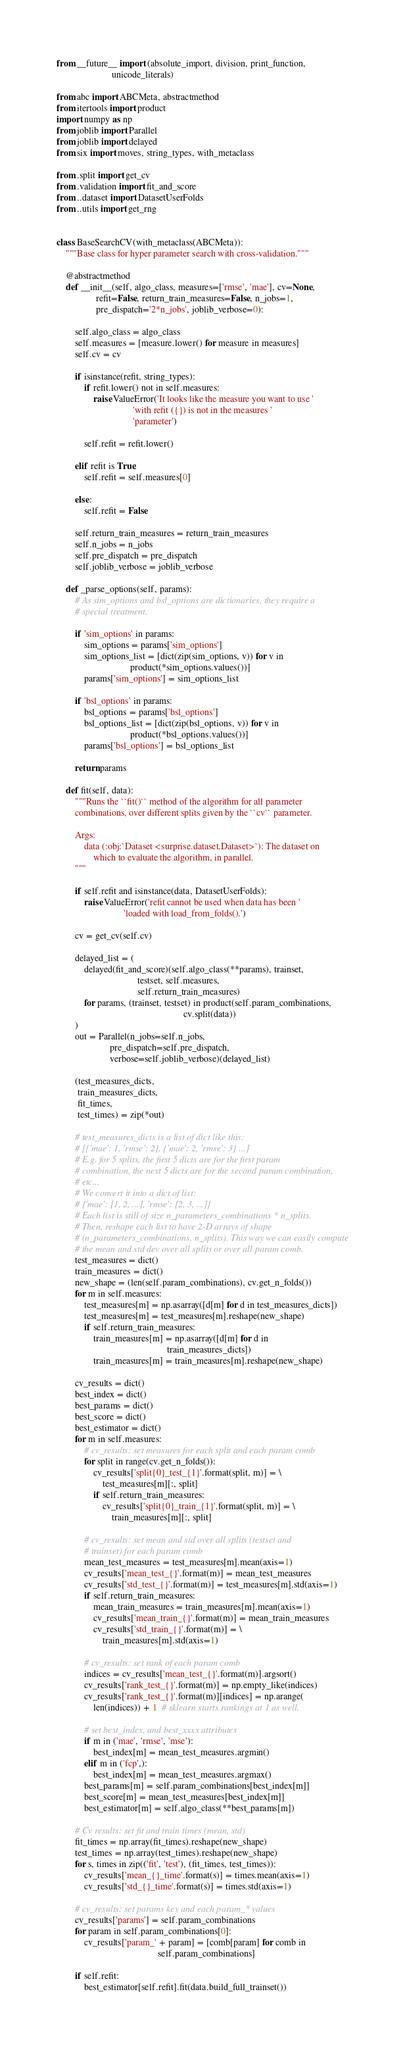Convert code to text. <code><loc_0><loc_0><loc_500><loc_500><_Python_>from __future__ import (absolute_import, division, print_function,
                        unicode_literals)

from abc import ABCMeta, abstractmethod
from itertools import product
import numpy as np
from joblib import Parallel
from joblib import delayed
from six import moves, string_types, with_metaclass

from .split import get_cv
from .validation import fit_and_score
from ..dataset import DatasetUserFolds
from ..utils import get_rng


class BaseSearchCV(with_metaclass(ABCMeta)):
    """Base class for hyper parameter search with cross-validation."""

    @abstractmethod
    def __init__(self, algo_class, measures=['rmse', 'mae'], cv=None,
                 refit=False, return_train_measures=False, n_jobs=1,
                 pre_dispatch='2*n_jobs', joblib_verbose=0):

        self.algo_class = algo_class
        self.measures = [measure.lower() for measure in measures]
        self.cv = cv

        if isinstance(refit, string_types):
            if refit.lower() not in self.measures:
                raise ValueError('It looks like the measure you want to use '
                                 'with refit ({}) is not in the measures '
                                 'parameter')

            self.refit = refit.lower()

        elif refit is True:
            self.refit = self.measures[0]

        else:
            self.refit = False

        self.return_train_measures = return_train_measures
        self.n_jobs = n_jobs
        self.pre_dispatch = pre_dispatch
        self.joblib_verbose = joblib_verbose

    def _parse_options(self, params):
        # As sim_options and bsl_options are dictionaries, they require a
        # special treatment.

        if 'sim_options' in params:
            sim_options = params['sim_options']
            sim_options_list = [dict(zip(sim_options, v)) for v in
                                product(*sim_options.values())]
            params['sim_options'] = sim_options_list

        if 'bsl_options' in params:
            bsl_options = params['bsl_options']
            bsl_options_list = [dict(zip(bsl_options, v)) for v in
                                product(*bsl_options.values())]
            params['bsl_options'] = bsl_options_list

        return params

    def fit(self, data):
        """Runs the ``fit()`` method of the algorithm for all parameter
        combinations, over different splits given by the ``cv`` parameter.

        Args:
            data (:obj:`Dataset <surprise.dataset.Dataset>`): The dataset on
                which to evaluate the algorithm, in parallel.
        """

        if self.refit and isinstance(data, DatasetUserFolds):
            raise ValueError('refit cannot be used when data has been '
                             'loaded with load_from_folds().')

        cv = get_cv(self.cv)

        delayed_list = (
            delayed(fit_and_score)(self.algo_class(**params), trainset,
                                   testset, self.measures,
                                   self.return_train_measures)
            for params, (trainset, testset) in product(self.param_combinations,
                                                       cv.split(data))
        )
        out = Parallel(n_jobs=self.n_jobs,
                       pre_dispatch=self.pre_dispatch,
                       verbose=self.joblib_verbose)(delayed_list)

        (test_measures_dicts,
         train_measures_dicts,
         fit_times,
         test_times) = zip(*out)

        # test_measures_dicts is a list of dict like this:
        # [{'mae': 1, 'rmse': 2}, {'mae': 2, 'rmse': 3} ...]
        # E.g. for 5 splits, the first 5 dicts are for the first param
        # combination, the next 5 dicts are for the second param combination,
        # etc...
        # We convert it into a dict of list:
        # {'mae': [1, 2, ...], 'rmse': [2, 3, ...]}
        # Each list is still of size n_parameters_combinations * n_splits.
        # Then, reshape each list to have 2-D arrays of shape
        # (n_parameters_combinations, n_splits). This way we can easily compute
        # the mean and std dev over all splits or over all param comb.
        test_measures = dict()
        train_measures = dict()
        new_shape = (len(self.param_combinations), cv.get_n_folds())
        for m in self.measures:
            test_measures[m] = np.asarray([d[m] for d in test_measures_dicts])
            test_measures[m] = test_measures[m].reshape(new_shape)
            if self.return_train_measures:
                train_measures[m] = np.asarray([d[m] for d in
                                                train_measures_dicts])
                train_measures[m] = train_measures[m].reshape(new_shape)

        cv_results = dict()
        best_index = dict()
        best_params = dict()
        best_score = dict()
        best_estimator = dict()
        for m in self.measures:
            # cv_results: set measures for each split and each param comb
            for split in range(cv.get_n_folds()):
                cv_results['split{0}_test_{1}'.format(split, m)] = \
                    test_measures[m][:, split]
                if self.return_train_measures:
                    cv_results['split{0}_train_{1}'.format(split, m)] = \
                        train_measures[m][:, split]

            # cv_results: set mean and std over all splits (testset and
            # trainset) for each param comb
            mean_test_measures = test_measures[m].mean(axis=1)
            cv_results['mean_test_{}'.format(m)] = mean_test_measures
            cv_results['std_test_{}'.format(m)] = test_measures[m].std(axis=1)
            if self.return_train_measures:
                mean_train_measures = train_measures[m].mean(axis=1)
                cv_results['mean_train_{}'.format(m)] = mean_train_measures
                cv_results['std_train_{}'.format(m)] = \
                    train_measures[m].std(axis=1)

            # cv_results: set rank of each param comb
            indices = cv_results['mean_test_{}'.format(m)].argsort()
            cv_results['rank_test_{}'.format(m)] = np.empty_like(indices)
            cv_results['rank_test_{}'.format(m)][indices] = np.arange(
                len(indices)) + 1  # sklearn starts rankings at 1 as well.

            # set best_index, and best_xxxx attributes
            if m in ('mae', 'rmse', 'mse'):
                best_index[m] = mean_test_measures.argmin()
            elif m in ('fcp',):
                best_index[m] = mean_test_measures.argmax()
            best_params[m] = self.param_combinations[best_index[m]]
            best_score[m] = mean_test_measures[best_index[m]]
            best_estimator[m] = self.algo_class(**best_params[m])

        # Cv results: set fit and train times (mean, std)
        fit_times = np.array(fit_times).reshape(new_shape)
        test_times = np.array(test_times).reshape(new_shape)
        for s, times in zip(('fit', 'test'), (fit_times, test_times)):
            cv_results['mean_{}_time'.format(s)] = times.mean(axis=1)
            cv_results['std_{}_time'.format(s)] = times.std(axis=1)

        # cv_results: set params key and each param_* values
        cv_results['params'] = self.param_combinations
        for param in self.param_combinations[0]:
            cv_results['param_' + param] = [comb[param] for comb in
                                            self.param_combinations]

        if self.refit:
            best_estimator[self.refit].fit(data.build_full_trainset())
</code> 